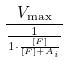<formula> <loc_0><loc_0><loc_500><loc_500>\frac { V _ { \max } } { \frac { 1 } { 1 \cdot \frac { [ F ] } { [ F ] + A _ { i } } } }</formula> 